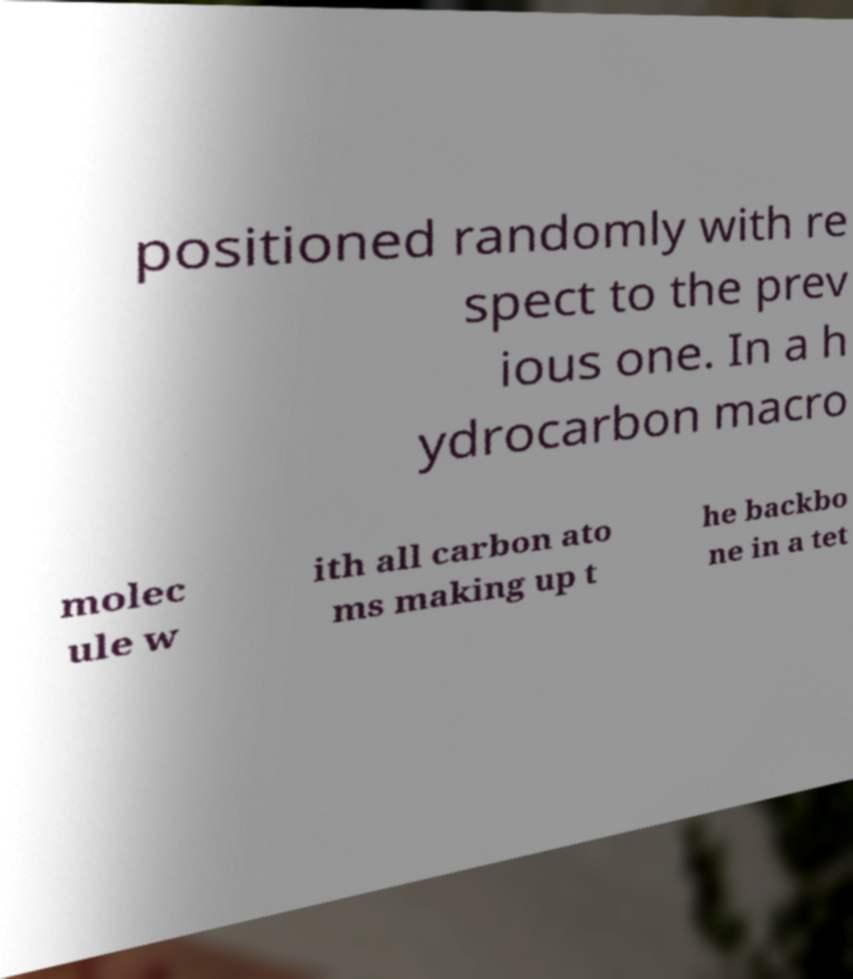Please identify and transcribe the text found in this image. positioned randomly with re spect to the prev ious one. In a h ydrocarbon macro molec ule w ith all carbon ato ms making up t he backbo ne in a tet 